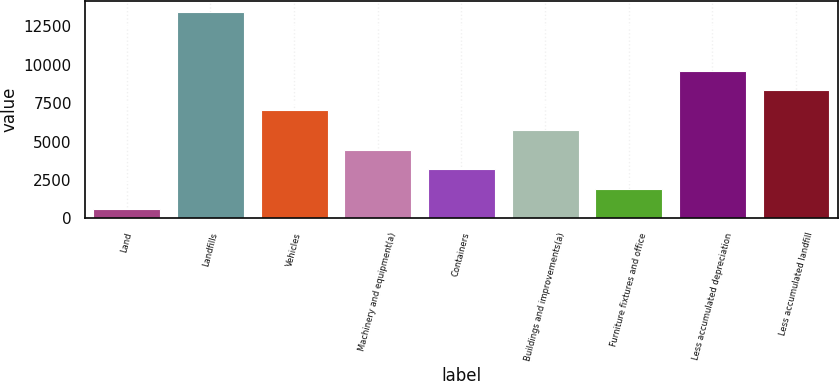Convert chart. <chart><loc_0><loc_0><loc_500><loc_500><bar_chart><fcel>Land<fcel>Landfills<fcel>Vehicles<fcel>Machinery and equipment(a)<fcel>Containers<fcel>Buildings and improvements(a)<fcel>Furniture fixtures and office<fcel>Less accumulated depreciation<fcel>Less accumulated landfill<nl><fcel>611<fcel>13463<fcel>7037<fcel>4466.6<fcel>3181.4<fcel>5751.8<fcel>1896.2<fcel>9607.4<fcel>8322.2<nl></chart> 